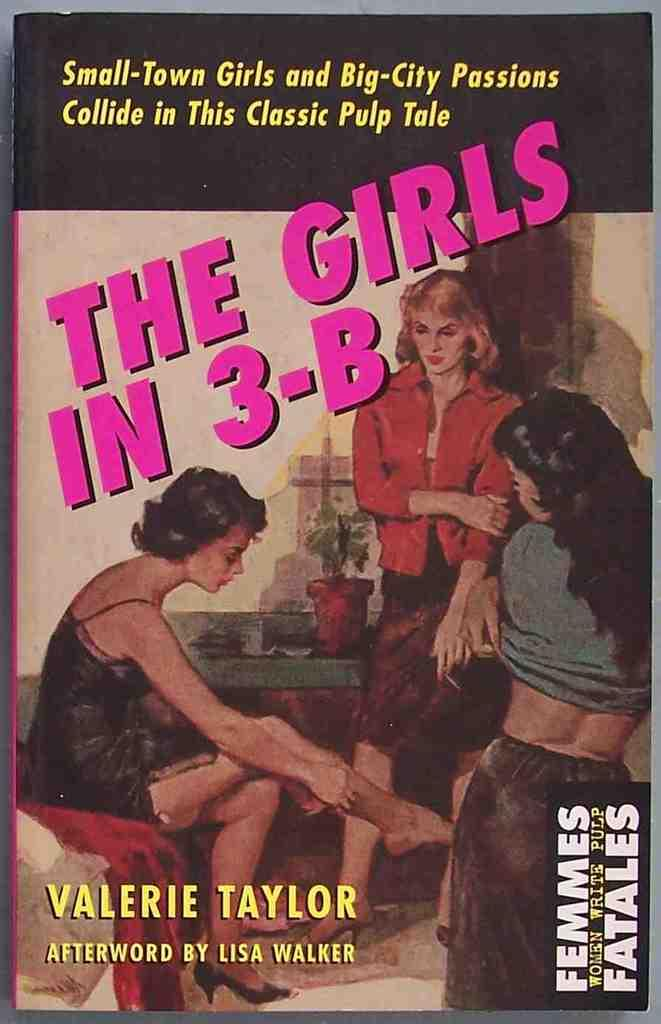Provide a one-sentence caption for the provided image. A cover of a book showing three girls called The Girls In 3-B. 